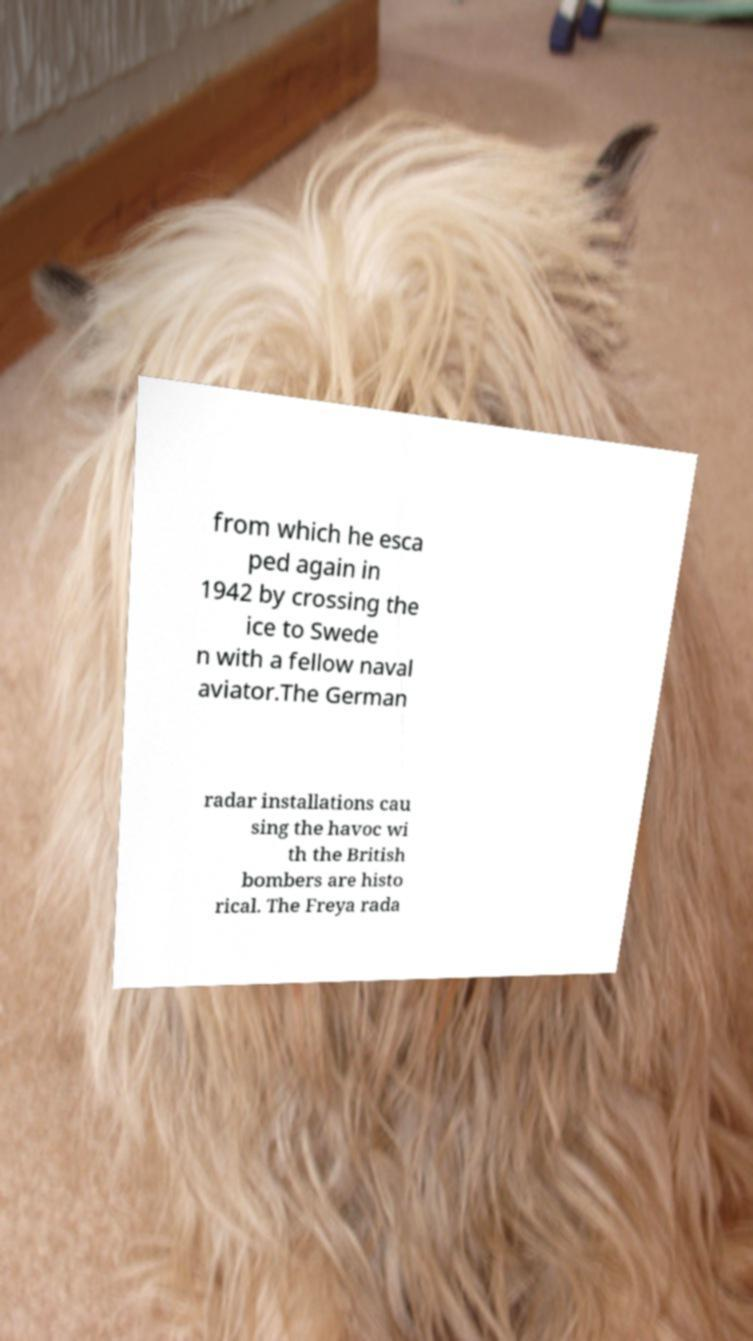Could you assist in decoding the text presented in this image and type it out clearly? from which he esca ped again in 1942 by crossing the ice to Swede n with a fellow naval aviator.The German radar installations cau sing the havoc wi th the British bombers are histo rical. The Freya rada 